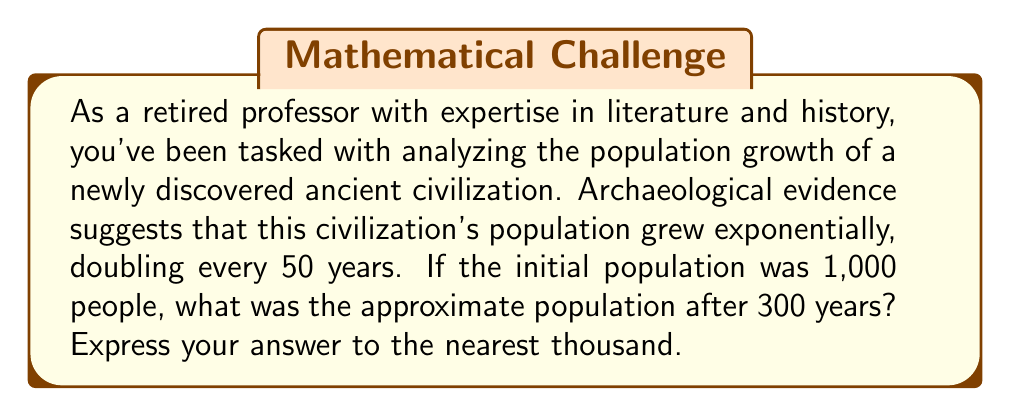What is the answer to this math problem? Let's approach this step-by-step using an exponential growth model:

1) The general formula for exponential growth is:

   $$P(t) = P_0 \cdot (1 + r)^t$$

   Where:
   $P(t)$ is the population at time $t$
   $P_0$ is the initial population
   $r$ is the growth rate
   $t$ is the time period

2) We know that the population doubles every 50 years. This means that:

   $$2 = (1 + r)^{50}$$

3) Solving for $r$:

   $$r = 2^{\frac{1}{50}} - 1 \approx 0.0139 \text{ or } 1.39\% \text{ per year}$$

4) Now we can use the exponential growth formula:

   $$P(300) = 1000 \cdot (1 + 0.0139)^{300}$$

5) Using a calculator or computer:

   $$P(300) \approx 1000 \cdot 62.4 \approx 62,400$$

6) Rounding to the nearest thousand:

   $$P(300) \approx 62,000$$

This aligns with our historical understanding that ancient civilizations could experience significant population growth over centuries, especially if they had access to abundant resources and faced few external threats.
Answer: 62,000 people 